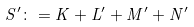<formula> <loc_0><loc_0><loc_500><loc_500>S ^ { \prime } \colon = K + L ^ { \prime } + M ^ { \prime } + N ^ { \prime }</formula> 